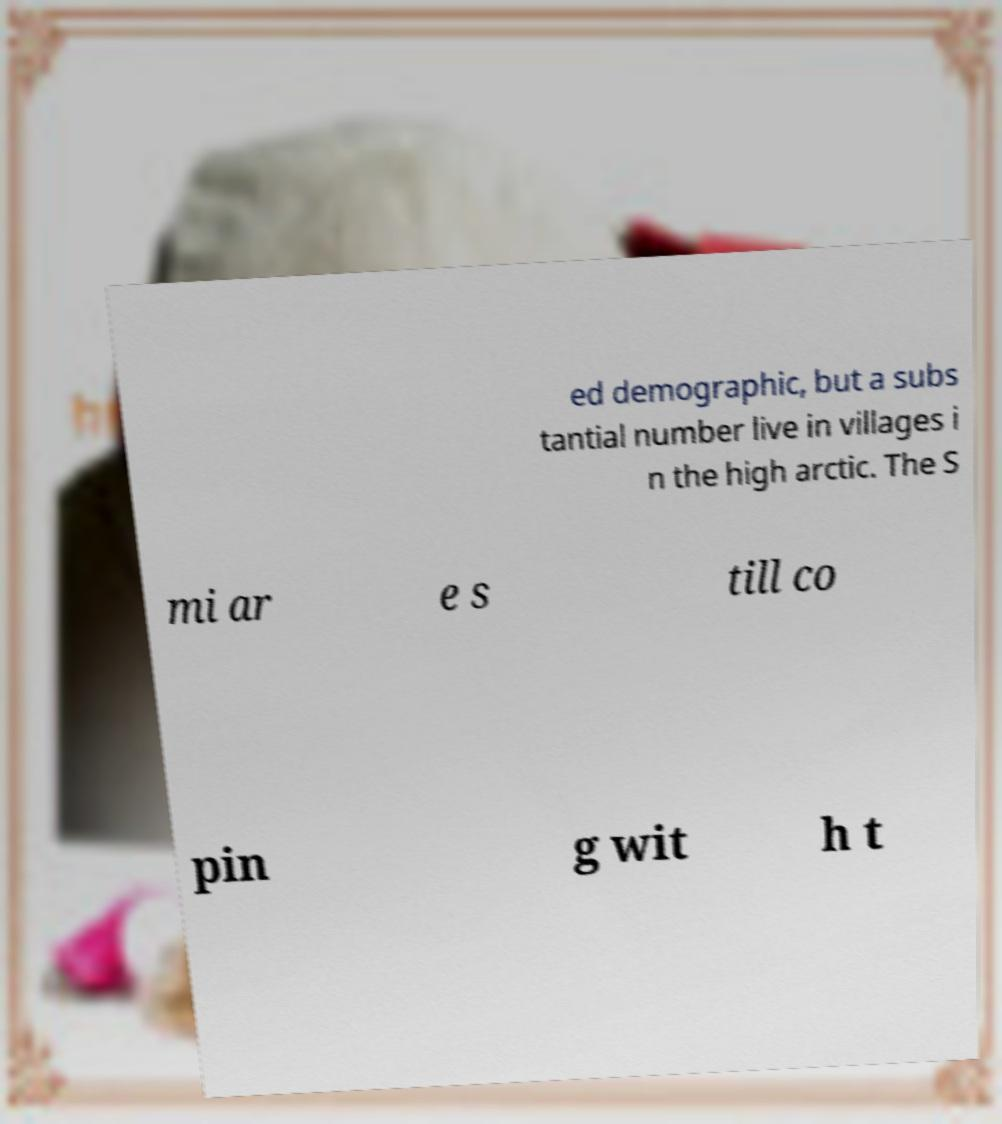Could you extract and type out the text from this image? ed demographic, but a subs tantial number live in villages i n the high arctic. The S mi ar e s till co pin g wit h t 